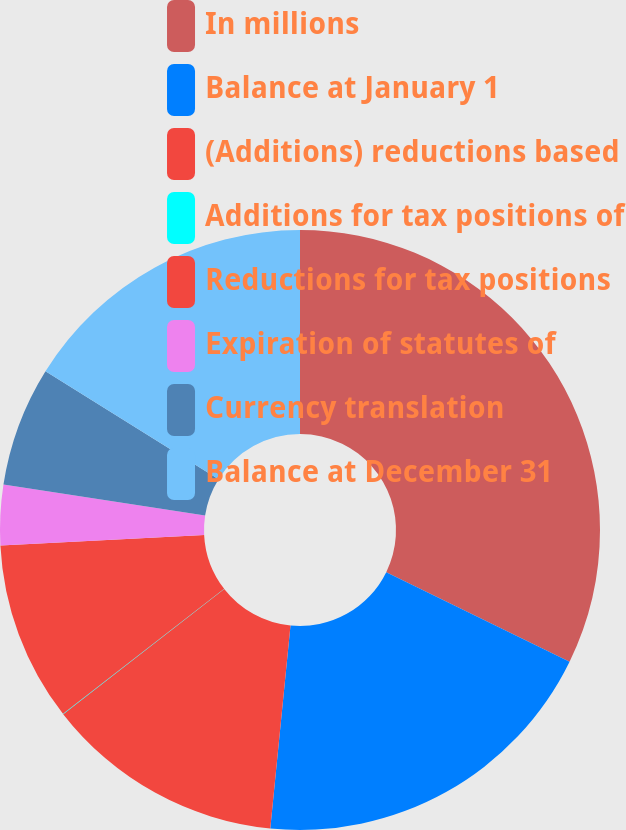Convert chart. <chart><loc_0><loc_0><loc_500><loc_500><pie_chart><fcel>In millions<fcel>Balance at January 1<fcel>(Additions) reductions based<fcel>Additions for tax positions of<fcel>Reductions for tax positions<fcel>Expiration of statutes of<fcel>Currency translation<fcel>Balance at December 31<nl><fcel>32.23%<fcel>19.35%<fcel>12.9%<fcel>0.02%<fcel>9.68%<fcel>3.24%<fcel>6.46%<fcel>16.12%<nl></chart> 